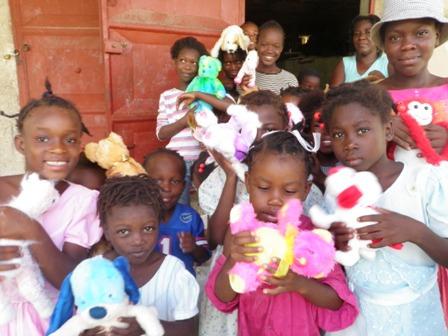Is this image from Africa?
Write a very short answer. Yes. Are these young ladies enjoying their toys?
Give a very brief answer. Yes. How many people do you see?
Quick response, please. 15. 